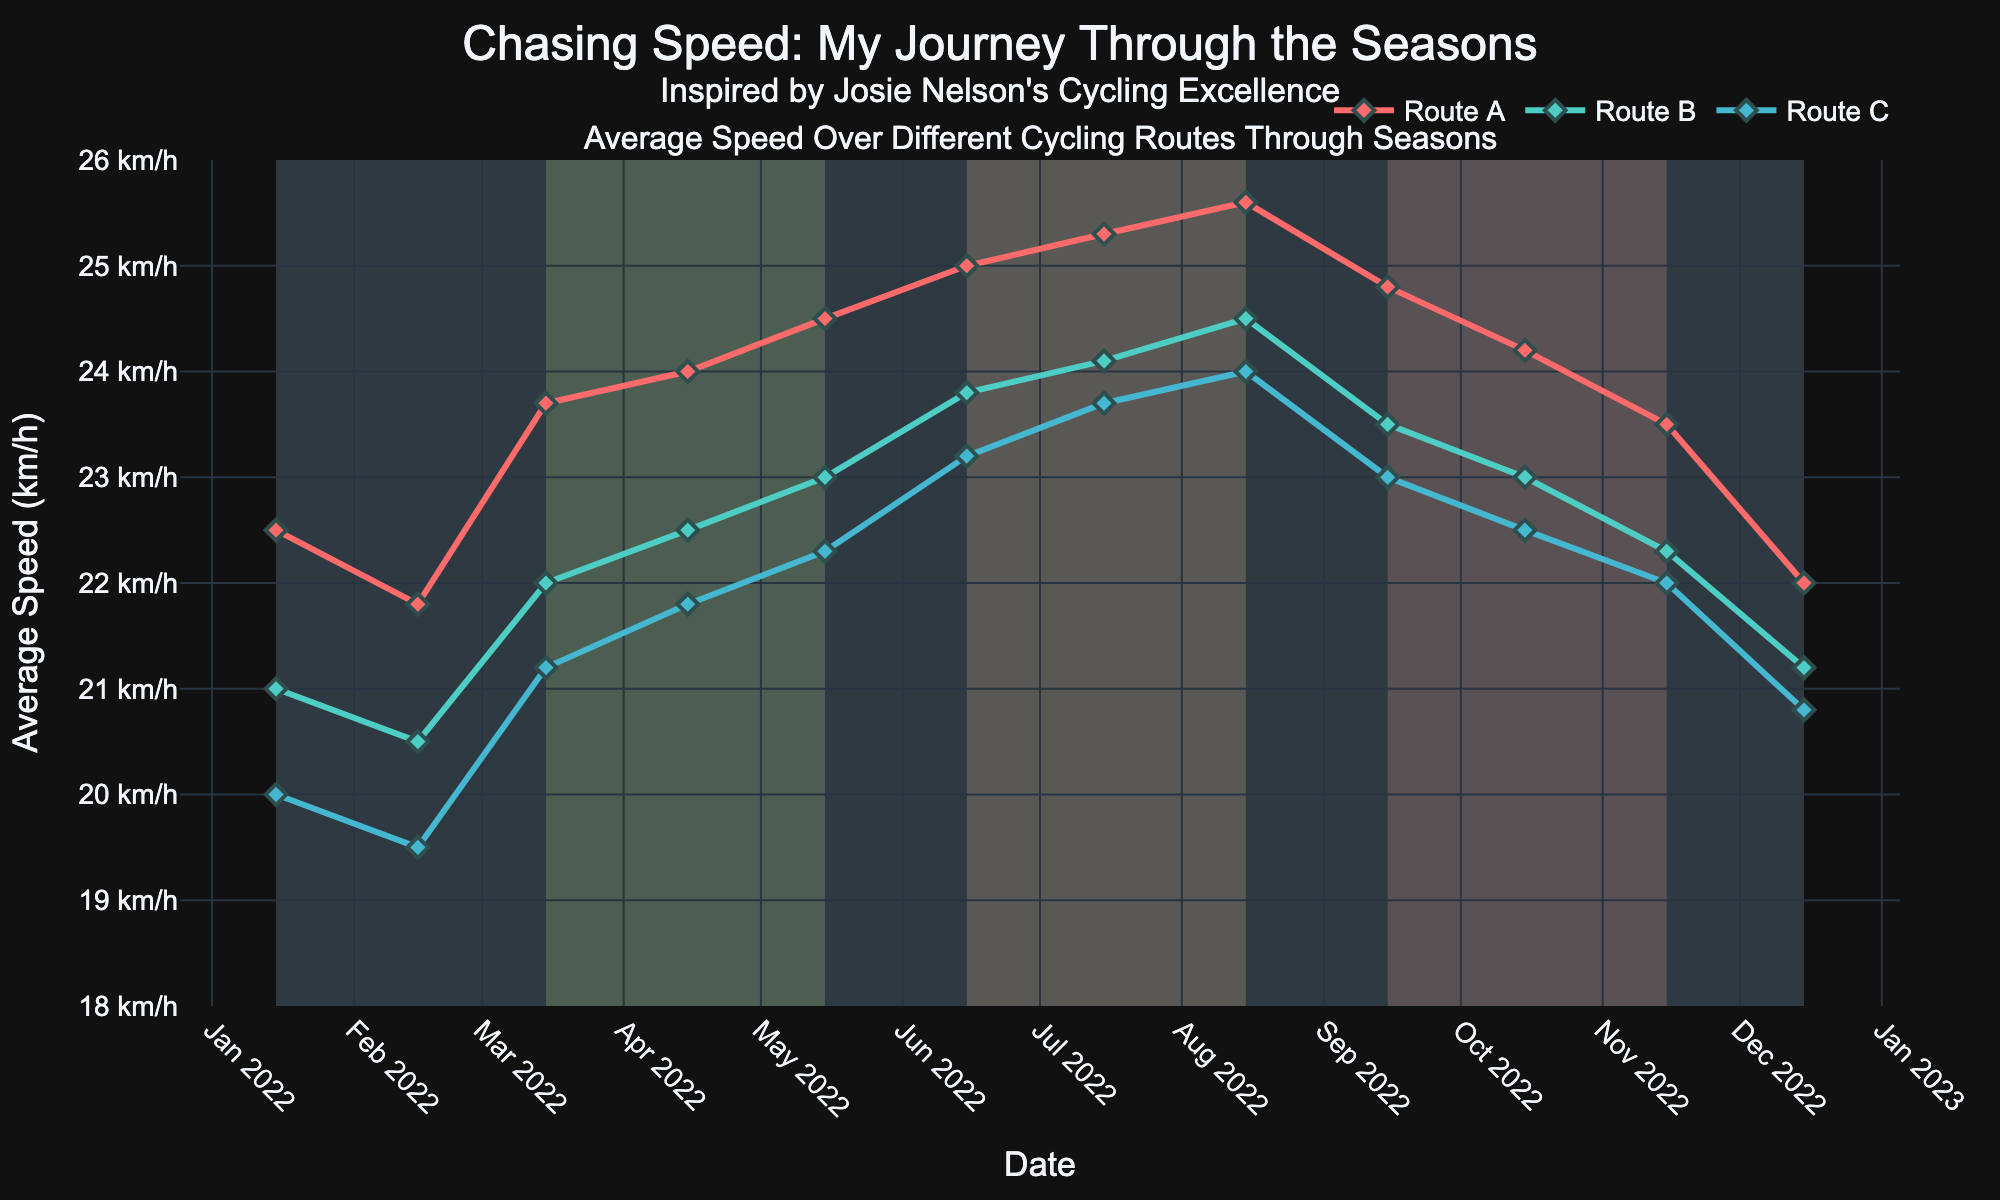What is the title of the plot? The title of the plot is located at the top. It reads, "Chasing Speed: My Journey Through the Seasons" with a subtitle "Inspired by Josie Nelson's Cycling Excellence".
Answer: Chasing Speed: My Journey Through the Seasons Which route has the highest average speed in Summer? By looking at the data points during Summer (June to August), Route A's average speed peaks the highest at 25.6 km/h in August.
Answer: Route A What is the average speed difference between Route A and Route C in August? In August, Route A has an average speed of 25.6 km/h and Route C has an average speed of 24.0 km/h. The difference is 25.6 - 24.0 = 1.6 km/h.
Answer: 1.6 km/h Which season shows the highest average speed for Route B? By looking at the plot, Route B peaks in Summer (June to August) where the speeds are 23.8, 24.1, and 24.5 km/h; the highest being 24.5 km/h in August.
Answer: Summer How do the speeds in Autumn compare to those in Winter for Route A? In Autumn, the speeds for Route A are 24.8, 24.2, and 23.5 km/h. In Winter, they are 22.5, 21.8, and 22.0 km/h. Clearly, speeds in Autumn are higher than those in Winter for Route A.
Answer: Autumn is higher What trend can be observed for Route C's speed from Winter to Summer? Route C's speed increases from Winter (20.0, 19.5, 20.8 km/h) to Spring (21.2, 21.8, 22.3 km/h) and continues to increase in Summer, peaking at 24.0 km/h in August.
Answer: Increasing trend What is the difference between the highest speed in Spring and the lowest speed in Autumn for Route A? The highest speed in Spring for Route A is 24.5 km/h in May. The lowest speed in Autumn for Route A is 23.5 km/h in November. The difference is 24.5 - 23.5 = 1.0 km/h.
Answer: 1.0 km/h Which season has the most consistent average speed for Route C? Route C shows the most consistent speed during Spring, where the speeds are 21.2, 21.8, and 22.3 km/h, showing smaller variations compared to other seasons.
Answer: Spring During which season does Route B experience its lowest average speed? Route B experiences its lowest average speed during Winter, with speeds being 21.0, 20.5, and 21.2 km/h.
Answer: Winter How does the speed of each route in December compare to each other? In December, Route A has an average speed of 22.0 km/h, Route B has 21.2 km/h, and Route C has 20.8 km/h. Thus, Route A > Route B > Route C.
Answer: Route A > Route B > Route C 